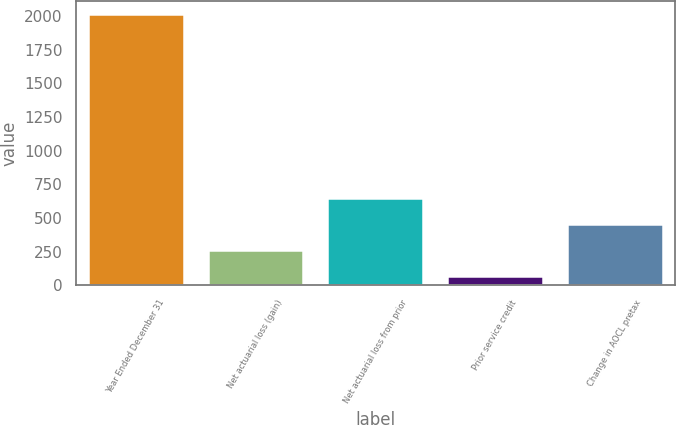<chart> <loc_0><loc_0><loc_500><loc_500><bar_chart><fcel>Year Ended December 31<fcel>Net actuarial loss (gain)<fcel>Net actuarial loss from prior<fcel>Prior service credit<fcel>Change in AOCL pretax<nl><fcel>2015<fcel>261.8<fcel>651.4<fcel>67<fcel>456.6<nl></chart> 